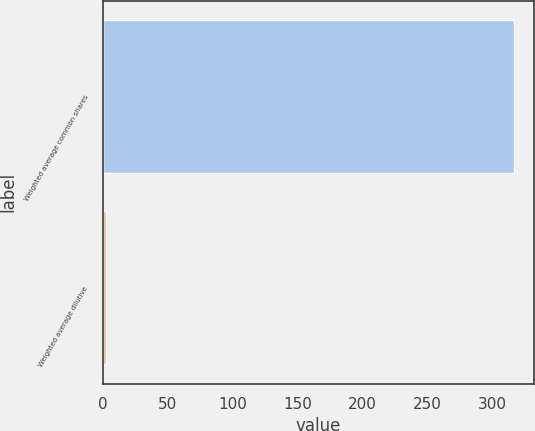<chart> <loc_0><loc_0><loc_500><loc_500><bar_chart><fcel>Weighted average common shares<fcel>Weighted average dilutive<nl><fcel>316.58<fcel>2.8<nl></chart> 